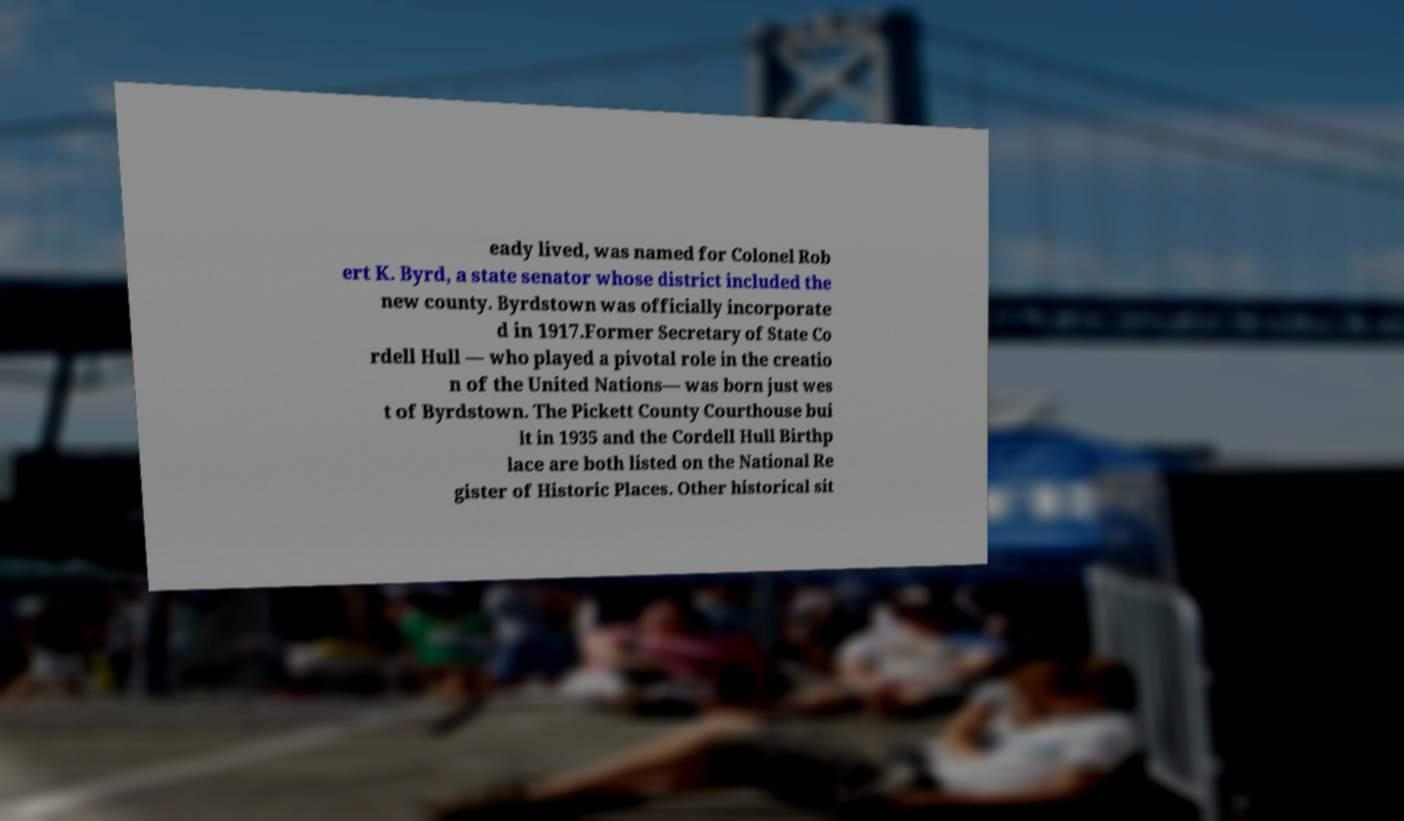There's text embedded in this image that I need extracted. Can you transcribe it verbatim? eady lived, was named for Colonel Rob ert K. Byrd, a state senator whose district included the new county. Byrdstown was officially incorporate d in 1917.Former Secretary of State Co rdell Hull — who played a pivotal role in the creatio n of the United Nations— was born just wes t of Byrdstown. The Pickett County Courthouse bui lt in 1935 and the Cordell Hull Birthp lace are both listed on the National Re gister of Historic Places. Other historical sit 